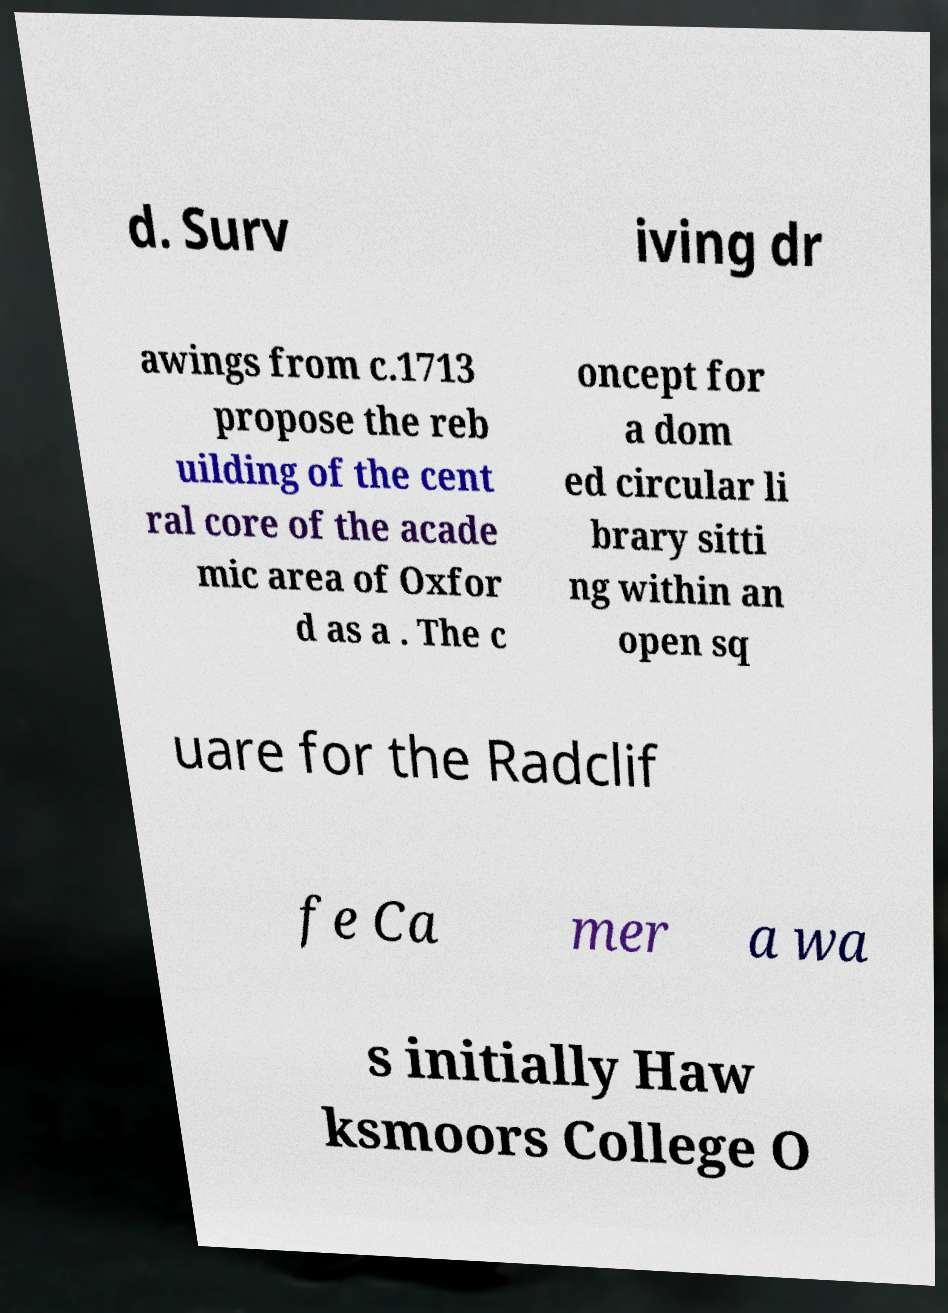Could you assist in decoding the text presented in this image and type it out clearly? d. Surv iving dr awings from c.1713 propose the reb uilding of the cent ral core of the acade mic area of Oxfor d as a . The c oncept for a dom ed circular li brary sitti ng within an open sq uare for the Radclif fe Ca mer a wa s initially Haw ksmoors College O 